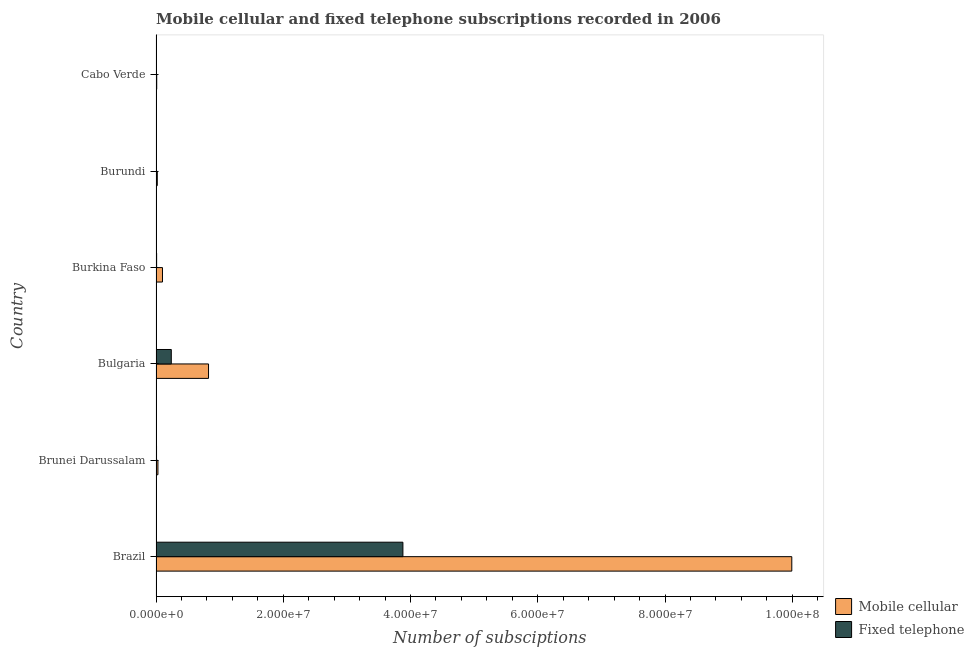Are the number of bars per tick equal to the number of legend labels?
Make the answer very short. Yes. How many bars are there on the 6th tick from the top?
Ensure brevity in your answer.  2. How many bars are there on the 5th tick from the bottom?
Ensure brevity in your answer.  2. What is the label of the 1st group of bars from the top?
Provide a short and direct response. Cabo Verde. What is the number of mobile cellular subscriptions in Bulgaria?
Your answer should be compact. 8.25e+06. Across all countries, what is the maximum number of mobile cellular subscriptions?
Make the answer very short. 9.99e+07. Across all countries, what is the minimum number of fixed telephone subscriptions?
Give a very brief answer. 2.79e+04. In which country was the number of fixed telephone subscriptions maximum?
Keep it short and to the point. Brazil. In which country was the number of mobile cellular subscriptions minimum?
Your answer should be compact. Cabo Verde. What is the total number of fixed telephone subscriptions in the graph?
Keep it short and to the point. 4.15e+07. What is the difference between the number of mobile cellular subscriptions in Brunei Darussalam and that in Burundi?
Your answer should be very brief. 1.01e+05. What is the difference between the number of mobile cellular subscriptions in Brazil and the number of fixed telephone subscriptions in Brunei Darussalam?
Provide a short and direct response. 9.98e+07. What is the average number of fixed telephone subscriptions per country?
Offer a very short reply. 6.91e+06. What is the difference between the number of mobile cellular subscriptions and number of fixed telephone subscriptions in Bulgaria?
Keep it short and to the point. 5.85e+06. In how many countries, is the number of fixed telephone subscriptions greater than 68000000 ?
Ensure brevity in your answer.  0. What is the ratio of the number of mobile cellular subscriptions in Bulgaria to that in Cabo Verde?
Offer a terse response. 75.82. Is the difference between the number of mobile cellular subscriptions in Burkina Faso and Cabo Verde greater than the difference between the number of fixed telephone subscriptions in Burkina Faso and Cabo Verde?
Provide a short and direct response. Yes. What is the difference between the highest and the second highest number of mobile cellular subscriptions?
Give a very brief answer. 9.17e+07. What is the difference between the highest and the lowest number of mobile cellular subscriptions?
Your answer should be very brief. 9.98e+07. What does the 1st bar from the top in Brunei Darussalam represents?
Offer a very short reply. Fixed telephone. What does the 2nd bar from the bottom in Bulgaria represents?
Provide a succinct answer. Fixed telephone. Are all the bars in the graph horizontal?
Make the answer very short. Yes. How many countries are there in the graph?
Offer a very short reply. 6. What is the difference between two consecutive major ticks on the X-axis?
Offer a terse response. 2.00e+07. Are the values on the major ticks of X-axis written in scientific E-notation?
Provide a succinct answer. Yes. Does the graph contain grids?
Make the answer very short. No. How many legend labels are there?
Your answer should be compact. 2. How are the legend labels stacked?
Keep it short and to the point. Vertical. What is the title of the graph?
Provide a succinct answer. Mobile cellular and fixed telephone subscriptions recorded in 2006. Does "Tetanus" appear as one of the legend labels in the graph?
Offer a terse response. No. What is the label or title of the X-axis?
Provide a short and direct response. Number of subsciptions. What is the Number of subsciptions in Mobile cellular in Brazil?
Your response must be concise. 9.99e+07. What is the Number of subsciptions in Fixed telephone in Brazil?
Give a very brief answer. 3.88e+07. What is the Number of subsciptions of Mobile cellular in Brunei Darussalam?
Offer a very short reply. 3.01e+05. What is the Number of subsciptions in Fixed telephone in Brunei Darussalam?
Provide a short and direct response. 8.02e+04. What is the Number of subsciptions in Mobile cellular in Bulgaria?
Your response must be concise. 8.25e+06. What is the Number of subsciptions of Fixed telephone in Bulgaria?
Keep it short and to the point. 2.40e+06. What is the Number of subsciptions of Mobile cellular in Burkina Faso?
Provide a short and direct response. 1.02e+06. What is the Number of subsciptions in Fixed telephone in Burkina Faso?
Ensure brevity in your answer.  9.48e+04. What is the Number of subsciptions of Fixed telephone in Burundi?
Your answer should be very brief. 2.79e+04. What is the Number of subsciptions of Mobile cellular in Cabo Verde?
Your answer should be very brief. 1.09e+05. What is the Number of subsciptions of Fixed telephone in Cabo Verde?
Give a very brief answer. 7.16e+04. Across all countries, what is the maximum Number of subsciptions in Mobile cellular?
Keep it short and to the point. 9.99e+07. Across all countries, what is the maximum Number of subsciptions in Fixed telephone?
Your answer should be compact. 3.88e+07. Across all countries, what is the minimum Number of subsciptions of Mobile cellular?
Provide a short and direct response. 1.09e+05. Across all countries, what is the minimum Number of subsciptions in Fixed telephone?
Provide a short and direct response. 2.79e+04. What is the total Number of subsciptions of Mobile cellular in the graph?
Offer a terse response. 1.10e+08. What is the total Number of subsciptions in Fixed telephone in the graph?
Give a very brief answer. 4.15e+07. What is the difference between the Number of subsciptions in Mobile cellular in Brazil and that in Brunei Darussalam?
Provide a succinct answer. 9.96e+07. What is the difference between the Number of subsciptions of Fixed telephone in Brazil and that in Brunei Darussalam?
Your response must be concise. 3.87e+07. What is the difference between the Number of subsciptions in Mobile cellular in Brazil and that in Bulgaria?
Offer a terse response. 9.17e+07. What is the difference between the Number of subsciptions of Fixed telephone in Brazil and that in Bulgaria?
Your answer should be compact. 3.64e+07. What is the difference between the Number of subsciptions in Mobile cellular in Brazil and that in Burkina Faso?
Offer a very short reply. 9.89e+07. What is the difference between the Number of subsciptions in Fixed telephone in Brazil and that in Burkina Faso?
Provide a short and direct response. 3.87e+07. What is the difference between the Number of subsciptions in Mobile cellular in Brazil and that in Burundi?
Ensure brevity in your answer.  9.97e+07. What is the difference between the Number of subsciptions of Fixed telephone in Brazil and that in Burundi?
Ensure brevity in your answer.  3.88e+07. What is the difference between the Number of subsciptions in Mobile cellular in Brazil and that in Cabo Verde?
Give a very brief answer. 9.98e+07. What is the difference between the Number of subsciptions in Fixed telephone in Brazil and that in Cabo Verde?
Keep it short and to the point. 3.87e+07. What is the difference between the Number of subsciptions in Mobile cellular in Brunei Darussalam and that in Bulgaria?
Provide a short and direct response. -7.95e+06. What is the difference between the Number of subsciptions in Fixed telephone in Brunei Darussalam and that in Bulgaria?
Keep it short and to the point. -2.32e+06. What is the difference between the Number of subsciptions in Mobile cellular in Brunei Darussalam and that in Burkina Faso?
Offer a very short reply. -7.15e+05. What is the difference between the Number of subsciptions of Fixed telephone in Brunei Darussalam and that in Burkina Faso?
Ensure brevity in your answer.  -1.46e+04. What is the difference between the Number of subsciptions in Mobile cellular in Brunei Darussalam and that in Burundi?
Give a very brief answer. 1.01e+05. What is the difference between the Number of subsciptions in Fixed telephone in Brunei Darussalam and that in Burundi?
Offer a very short reply. 5.23e+04. What is the difference between the Number of subsciptions of Mobile cellular in Brunei Darussalam and that in Cabo Verde?
Your answer should be very brief. 1.93e+05. What is the difference between the Number of subsciptions of Fixed telephone in Brunei Darussalam and that in Cabo Verde?
Your answer should be compact. 8598. What is the difference between the Number of subsciptions in Mobile cellular in Bulgaria and that in Burkina Faso?
Ensure brevity in your answer.  7.24e+06. What is the difference between the Number of subsciptions of Fixed telephone in Bulgaria and that in Burkina Faso?
Your answer should be compact. 2.30e+06. What is the difference between the Number of subsciptions in Mobile cellular in Bulgaria and that in Burundi?
Offer a terse response. 8.05e+06. What is the difference between the Number of subsciptions in Fixed telephone in Bulgaria and that in Burundi?
Provide a succinct answer. 2.37e+06. What is the difference between the Number of subsciptions in Mobile cellular in Bulgaria and that in Cabo Verde?
Ensure brevity in your answer.  8.14e+06. What is the difference between the Number of subsciptions in Fixed telephone in Bulgaria and that in Cabo Verde?
Ensure brevity in your answer.  2.33e+06. What is the difference between the Number of subsciptions of Mobile cellular in Burkina Faso and that in Burundi?
Your response must be concise. 8.17e+05. What is the difference between the Number of subsciptions of Fixed telephone in Burkina Faso and that in Burundi?
Offer a very short reply. 6.69e+04. What is the difference between the Number of subsciptions in Mobile cellular in Burkina Faso and that in Cabo Verde?
Offer a very short reply. 9.08e+05. What is the difference between the Number of subsciptions of Fixed telephone in Burkina Faso and that in Cabo Verde?
Ensure brevity in your answer.  2.32e+04. What is the difference between the Number of subsciptions in Mobile cellular in Burundi and that in Cabo Verde?
Keep it short and to the point. 9.11e+04. What is the difference between the Number of subsciptions in Fixed telephone in Burundi and that in Cabo Verde?
Ensure brevity in your answer.  -4.37e+04. What is the difference between the Number of subsciptions in Mobile cellular in Brazil and the Number of subsciptions in Fixed telephone in Brunei Darussalam?
Give a very brief answer. 9.98e+07. What is the difference between the Number of subsciptions in Mobile cellular in Brazil and the Number of subsciptions in Fixed telephone in Bulgaria?
Offer a terse response. 9.75e+07. What is the difference between the Number of subsciptions in Mobile cellular in Brazil and the Number of subsciptions in Fixed telephone in Burkina Faso?
Keep it short and to the point. 9.98e+07. What is the difference between the Number of subsciptions in Mobile cellular in Brazil and the Number of subsciptions in Fixed telephone in Burundi?
Ensure brevity in your answer.  9.99e+07. What is the difference between the Number of subsciptions of Mobile cellular in Brazil and the Number of subsciptions of Fixed telephone in Cabo Verde?
Give a very brief answer. 9.98e+07. What is the difference between the Number of subsciptions in Mobile cellular in Brunei Darussalam and the Number of subsciptions in Fixed telephone in Bulgaria?
Provide a short and direct response. -2.10e+06. What is the difference between the Number of subsciptions of Mobile cellular in Brunei Darussalam and the Number of subsciptions of Fixed telephone in Burkina Faso?
Keep it short and to the point. 2.07e+05. What is the difference between the Number of subsciptions in Mobile cellular in Brunei Darussalam and the Number of subsciptions in Fixed telephone in Burundi?
Your answer should be compact. 2.74e+05. What is the difference between the Number of subsciptions in Mobile cellular in Brunei Darussalam and the Number of subsciptions in Fixed telephone in Cabo Verde?
Your answer should be compact. 2.30e+05. What is the difference between the Number of subsciptions of Mobile cellular in Bulgaria and the Number of subsciptions of Fixed telephone in Burkina Faso?
Your answer should be very brief. 8.16e+06. What is the difference between the Number of subsciptions of Mobile cellular in Bulgaria and the Number of subsciptions of Fixed telephone in Burundi?
Provide a succinct answer. 8.23e+06. What is the difference between the Number of subsciptions of Mobile cellular in Bulgaria and the Number of subsciptions of Fixed telephone in Cabo Verde?
Provide a succinct answer. 8.18e+06. What is the difference between the Number of subsciptions in Mobile cellular in Burkina Faso and the Number of subsciptions in Fixed telephone in Burundi?
Your answer should be compact. 9.89e+05. What is the difference between the Number of subsciptions of Mobile cellular in Burkina Faso and the Number of subsciptions of Fixed telephone in Cabo Verde?
Your answer should be compact. 9.45e+05. What is the difference between the Number of subsciptions in Mobile cellular in Burundi and the Number of subsciptions in Fixed telephone in Cabo Verde?
Your answer should be very brief. 1.28e+05. What is the average Number of subsciptions of Mobile cellular per country?
Your answer should be compact. 1.83e+07. What is the average Number of subsciptions of Fixed telephone per country?
Provide a succinct answer. 6.91e+06. What is the difference between the Number of subsciptions in Mobile cellular and Number of subsciptions in Fixed telephone in Brazil?
Make the answer very short. 6.11e+07. What is the difference between the Number of subsciptions of Mobile cellular and Number of subsciptions of Fixed telephone in Brunei Darussalam?
Ensure brevity in your answer.  2.21e+05. What is the difference between the Number of subsciptions in Mobile cellular and Number of subsciptions in Fixed telephone in Bulgaria?
Your answer should be very brief. 5.85e+06. What is the difference between the Number of subsciptions of Mobile cellular and Number of subsciptions of Fixed telephone in Burkina Faso?
Your response must be concise. 9.22e+05. What is the difference between the Number of subsciptions in Mobile cellular and Number of subsciptions in Fixed telephone in Burundi?
Your answer should be very brief. 1.72e+05. What is the difference between the Number of subsciptions of Mobile cellular and Number of subsciptions of Fixed telephone in Cabo Verde?
Provide a short and direct response. 3.73e+04. What is the ratio of the Number of subsciptions of Mobile cellular in Brazil to that in Brunei Darussalam?
Your response must be concise. 331.51. What is the ratio of the Number of subsciptions in Fixed telephone in Brazil to that in Brunei Darussalam?
Offer a very short reply. 483.94. What is the ratio of the Number of subsciptions in Mobile cellular in Brazil to that in Bulgaria?
Keep it short and to the point. 12.11. What is the ratio of the Number of subsciptions in Fixed telephone in Brazil to that in Bulgaria?
Ensure brevity in your answer.  16.17. What is the ratio of the Number of subsciptions of Mobile cellular in Brazil to that in Burkina Faso?
Offer a terse response. 98.29. What is the ratio of the Number of subsciptions in Fixed telephone in Brazil to that in Burkina Faso?
Keep it short and to the point. 409.47. What is the ratio of the Number of subsciptions in Mobile cellular in Brazil to that in Burundi?
Offer a very short reply. 499.59. What is the ratio of the Number of subsciptions in Fixed telephone in Brazil to that in Burundi?
Your answer should be very brief. 1391.39. What is the ratio of the Number of subsciptions of Mobile cellular in Brazil to that in Cabo Verde?
Your response must be concise. 917.88. What is the ratio of the Number of subsciptions of Fixed telephone in Brazil to that in Cabo Verde?
Offer a terse response. 542.07. What is the ratio of the Number of subsciptions in Mobile cellular in Brunei Darussalam to that in Bulgaria?
Make the answer very short. 0.04. What is the ratio of the Number of subsciptions in Fixed telephone in Brunei Darussalam to that in Bulgaria?
Your answer should be very brief. 0.03. What is the ratio of the Number of subsciptions in Mobile cellular in Brunei Darussalam to that in Burkina Faso?
Make the answer very short. 0.3. What is the ratio of the Number of subsciptions of Fixed telephone in Brunei Darussalam to that in Burkina Faso?
Provide a short and direct response. 0.85. What is the ratio of the Number of subsciptions of Mobile cellular in Brunei Darussalam to that in Burundi?
Offer a terse response. 1.51. What is the ratio of the Number of subsciptions of Fixed telephone in Brunei Darussalam to that in Burundi?
Offer a very short reply. 2.88. What is the ratio of the Number of subsciptions of Mobile cellular in Brunei Darussalam to that in Cabo Verde?
Offer a terse response. 2.77. What is the ratio of the Number of subsciptions in Fixed telephone in Brunei Darussalam to that in Cabo Verde?
Your response must be concise. 1.12. What is the ratio of the Number of subsciptions in Mobile cellular in Bulgaria to that in Burkina Faso?
Give a very brief answer. 8.12. What is the ratio of the Number of subsciptions in Fixed telephone in Bulgaria to that in Burkina Faso?
Your answer should be compact. 25.32. What is the ratio of the Number of subsciptions in Mobile cellular in Bulgaria to that in Burundi?
Keep it short and to the point. 41.27. What is the ratio of the Number of subsciptions in Fixed telephone in Bulgaria to that in Burundi?
Your answer should be compact. 86.04. What is the ratio of the Number of subsciptions of Mobile cellular in Bulgaria to that in Cabo Verde?
Make the answer very short. 75.82. What is the ratio of the Number of subsciptions of Fixed telephone in Bulgaria to that in Cabo Verde?
Your response must be concise. 33.52. What is the ratio of the Number of subsciptions of Mobile cellular in Burkina Faso to that in Burundi?
Your answer should be very brief. 5.08. What is the ratio of the Number of subsciptions of Fixed telephone in Burkina Faso to that in Burundi?
Make the answer very short. 3.4. What is the ratio of the Number of subsciptions of Mobile cellular in Burkina Faso to that in Cabo Verde?
Your response must be concise. 9.34. What is the ratio of the Number of subsciptions of Fixed telephone in Burkina Faso to that in Cabo Verde?
Your answer should be very brief. 1.32. What is the ratio of the Number of subsciptions of Mobile cellular in Burundi to that in Cabo Verde?
Provide a succinct answer. 1.84. What is the ratio of the Number of subsciptions of Fixed telephone in Burundi to that in Cabo Verde?
Ensure brevity in your answer.  0.39. What is the difference between the highest and the second highest Number of subsciptions in Mobile cellular?
Provide a short and direct response. 9.17e+07. What is the difference between the highest and the second highest Number of subsciptions of Fixed telephone?
Your answer should be compact. 3.64e+07. What is the difference between the highest and the lowest Number of subsciptions of Mobile cellular?
Keep it short and to the point. 9.98e+07. What is the difference between the highest and the lowest Number of subsciptions in Fixed telephone?
Offer a very short reply. 3.88e+07. 